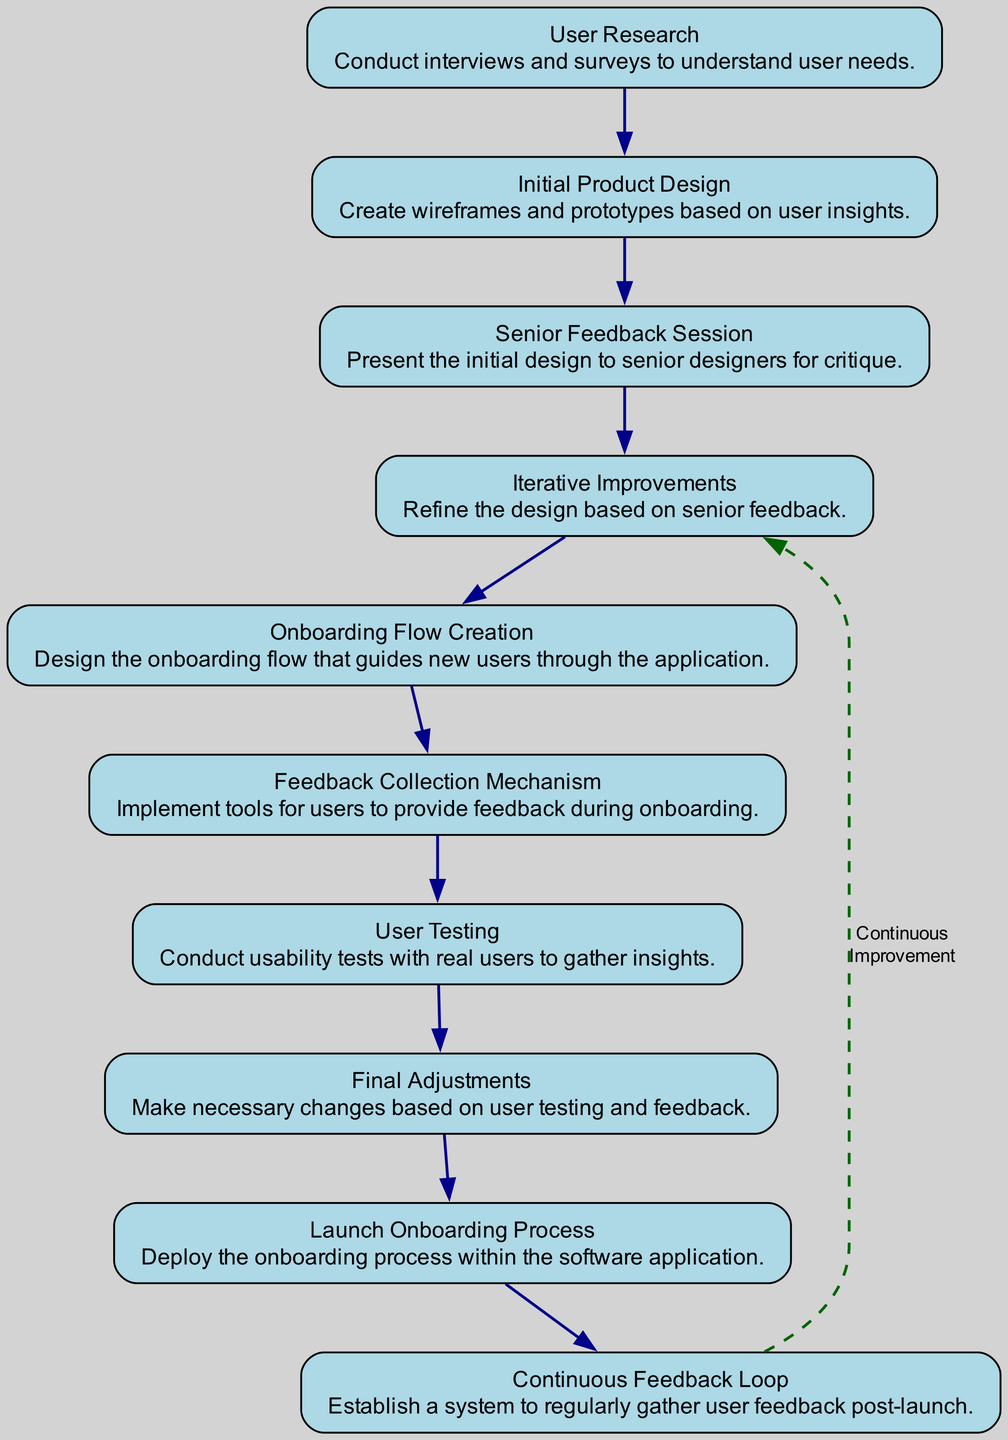What is the first step in the onboarding process? The first step according to the flow chart is "User Research." It is explicitly the starting node in the diagram indicating the beginning of the onboarding process.
Answer: User Research How many feedback collection methods are mentioned? The flow chart indicates one specific method for feedback collection, which is "Feedback Collection Mechanism." This is the only explicitly pointed step regarding user feedback during onboarding.
Answer: One Which step comes after "Senior Feedback Session"? Following the "Senior Feedback Session" in the flow is "Iterative Improvements." This is directly connected as the next node in the sequence of the process.
Answer: Iterative Improvements What process is launched after making final adjustments? After the "Final Adjustments," the next step in the sequence is "Launch Onboarding Process," indicating this is the action taken post-adjustments.
Answer: Launch Onboarding Process What type of loop is established after the continuous feedback loop? The diagram indicates a "Continuous Feedback Loop," which is mentioned explicitly as a system for ongoing user feedback, establishing iterative improvement.
Answer: Continuous Feedback Loop How many total nodes are present in the diagram? Counting each node listed in the diagram, there are ten individual elements present, which are connected sequentially to depict the onboarding process.
Answer: Ten Which step emphasizes user testing? The step designated for user testing is "User Testing," which is directly labeled and recognized in the flow chart to assess usability with real users.
Answer: User Testing What is the last step in the onboarding process? The last step as illustrated in the flow chart is "Continuous Feedback Loop," signifying an ongoing process for gathering feedback after initial onboarding.
Answer: Continuous Feedback Loop How does the diagram indicate improvement is made continuously? Continuous improvement is represented in the diagram as a feedback loop leading back from the "Continuous Feedback Loop" to "Iterative Improvements," demonstrating that feedback is used to refine the onboarding process continuously.
Answer: Continuous Improvement 